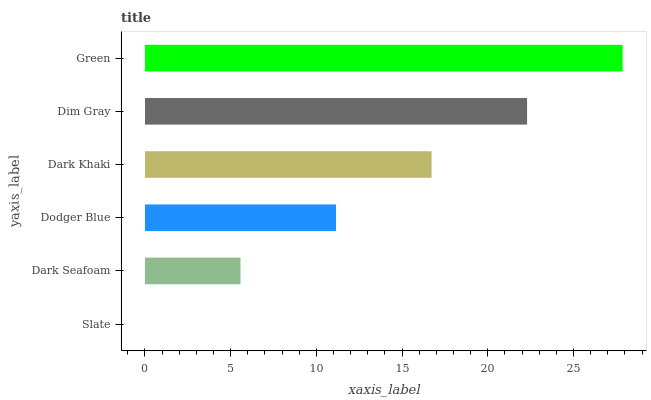Is Slate the minimum?
Answer yes or no. Yes. Is Green the maximum?
Answer yes or no. Yes. Is Dark Seafoam the minimum?
Answer yes or no. No. Is Dark Seafoam the maximum?
Answer yes or no. No. Is Dark Seafoam greater than Slate?
Answer yes or no. Yes. Is Slate less than Dark Seafoam?
Answer yes or no. Yes. Is Slate greater than Dark Seafoam?
Answer yes or no. No. Is Dark Seafoam less than Slate?
Answer yes or no. No. Is Dark Khaki the high median?
Answer yes or no. Yes. Is Dodger Blue the low median?
Answer yes or no. Yes. Is Dark Seafoam the high median?
Answer yes or no. No. Is Dark Khaki the low median?
Answer yes or no. No. 